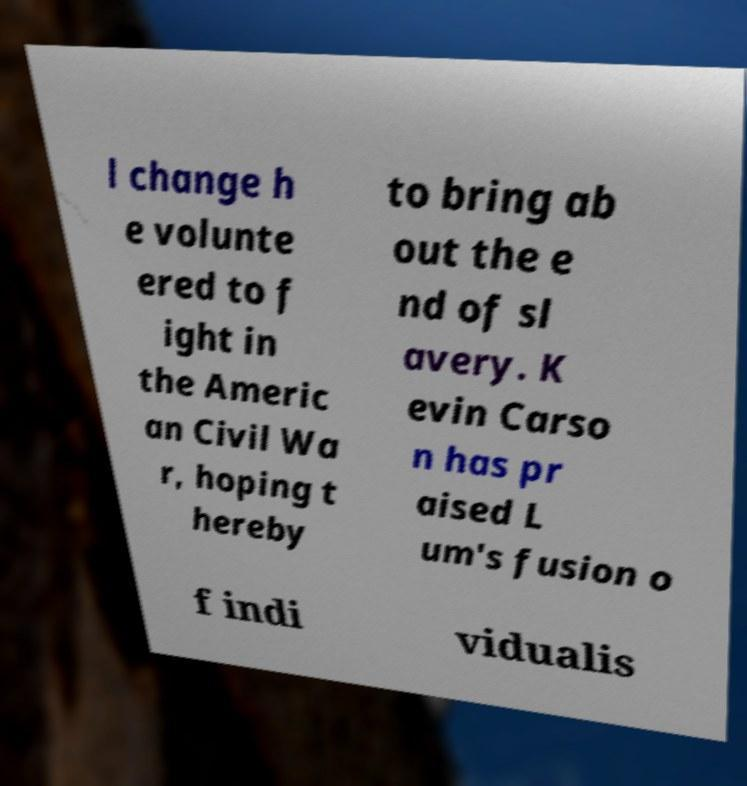There's text embedded in this image that I need extracted. Can you transcribe it verbatim? l change h e volunte ered to f ight in the Americ an Civil Wa r, hoping t hereby to bring ab out the e nd of sl avery. K evin Carso n has pr aised L um's fusion o f indi vidualis 